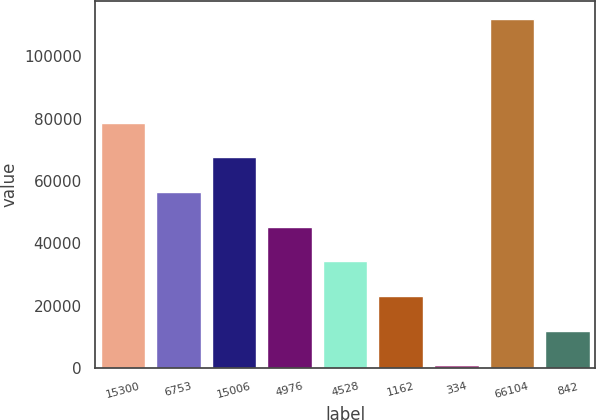Convert chart. <chart><loc_0><loc_0><loc_500><loc_500><bar_chart><fcel>15300<fcel>6753<fcel>15006<fcel>4976<fcel>4528<fcel>1162<fcel>334<fcel>66104<fcel>842<nl><fcel>78715.8<fcel>56473<fcel>67594.4<fcel>45351.6<fcel>34230.2<fcel>23108.8<fcel>866<fcel>112080<fcel>11987.4<nl></chart> 